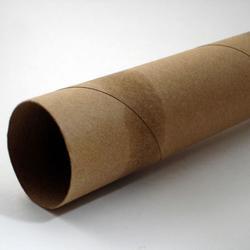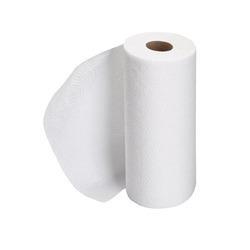The first image is the image on the left, the second image is the image on the right. Given the left and right images, does the statement "A hand is reaching toward a white towel in a dispenser." hold true? Answer yes or no. No. The first image is the image on the left, the second image is the image on the right. Assess this claim about the two images: "The image on the left shows a human hand holding a paper towel.". Correct or not? Answer yes or no. No. 